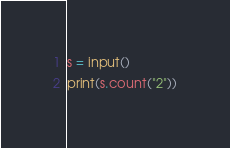<code> <loc_0><loc_0><loc_500><loc_500><_Python_>s = input()
print(s.count("2"))</code> 